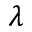Convert formula to latex. <formula><loc_0><loc_0><loc_500><loc_500>\lambda</formula> 